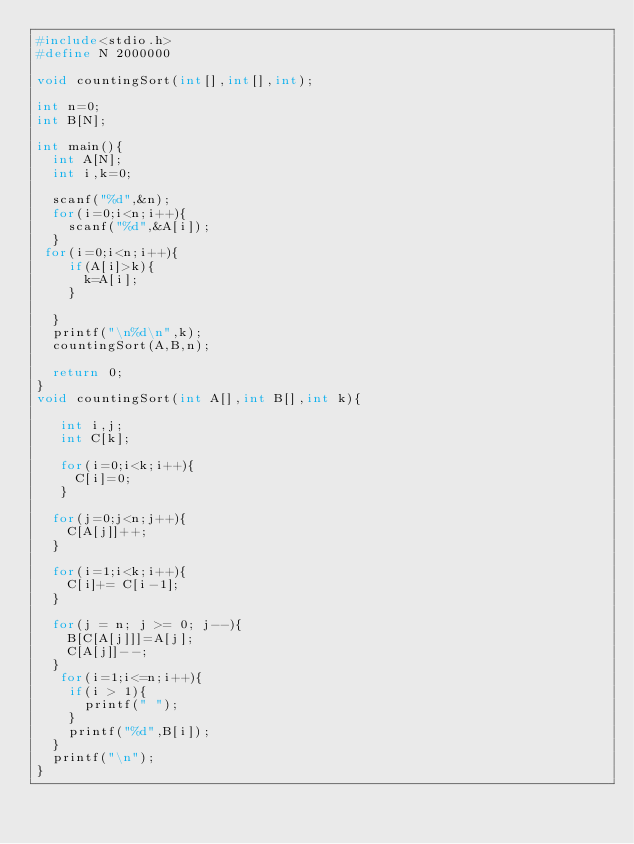Convert code to text. <code><loc_0><loc_0><loc_500><loc_500><_C_>#include<stdio.h>
#define N 2000000

void countingSort(int[],int[],int);

int n=0;
int B[N];

int main(){
  int A[N];
  int i,k=0;

  scanf("%d",&n);
  for(i=0;i<n;i++){
    scanf("%d",&A[i]);
  }
 for(i=0;i<n;i++){
    if(A[i]>k){
      k=A[i];
    }

  }
  printf("\n%d\n",k);
  countingSort(A,B,n);

  return 0;
}
void countingSort(int A[],int B[],int k){

   int i,j;
   int C[k];

   for(i=0;i<k;i++){
     C[i]=0;
   }  

  for(j=0;j<n;j++){
    C[A[j]]++;
  }

  for(i=1;i<k;i++){
    C[i]+= C[i-1];
  }

  for(j = n; j >= 0; j--){
    B[C[A[j]]]=A[j];
    C[A[j]]--;
  }
   for(i=1;i<=n;i++){
    if(i > 1){
      printf(" ");
    }
    printf("%d",B[i]);
  }
  printf("\n");
}</code> 